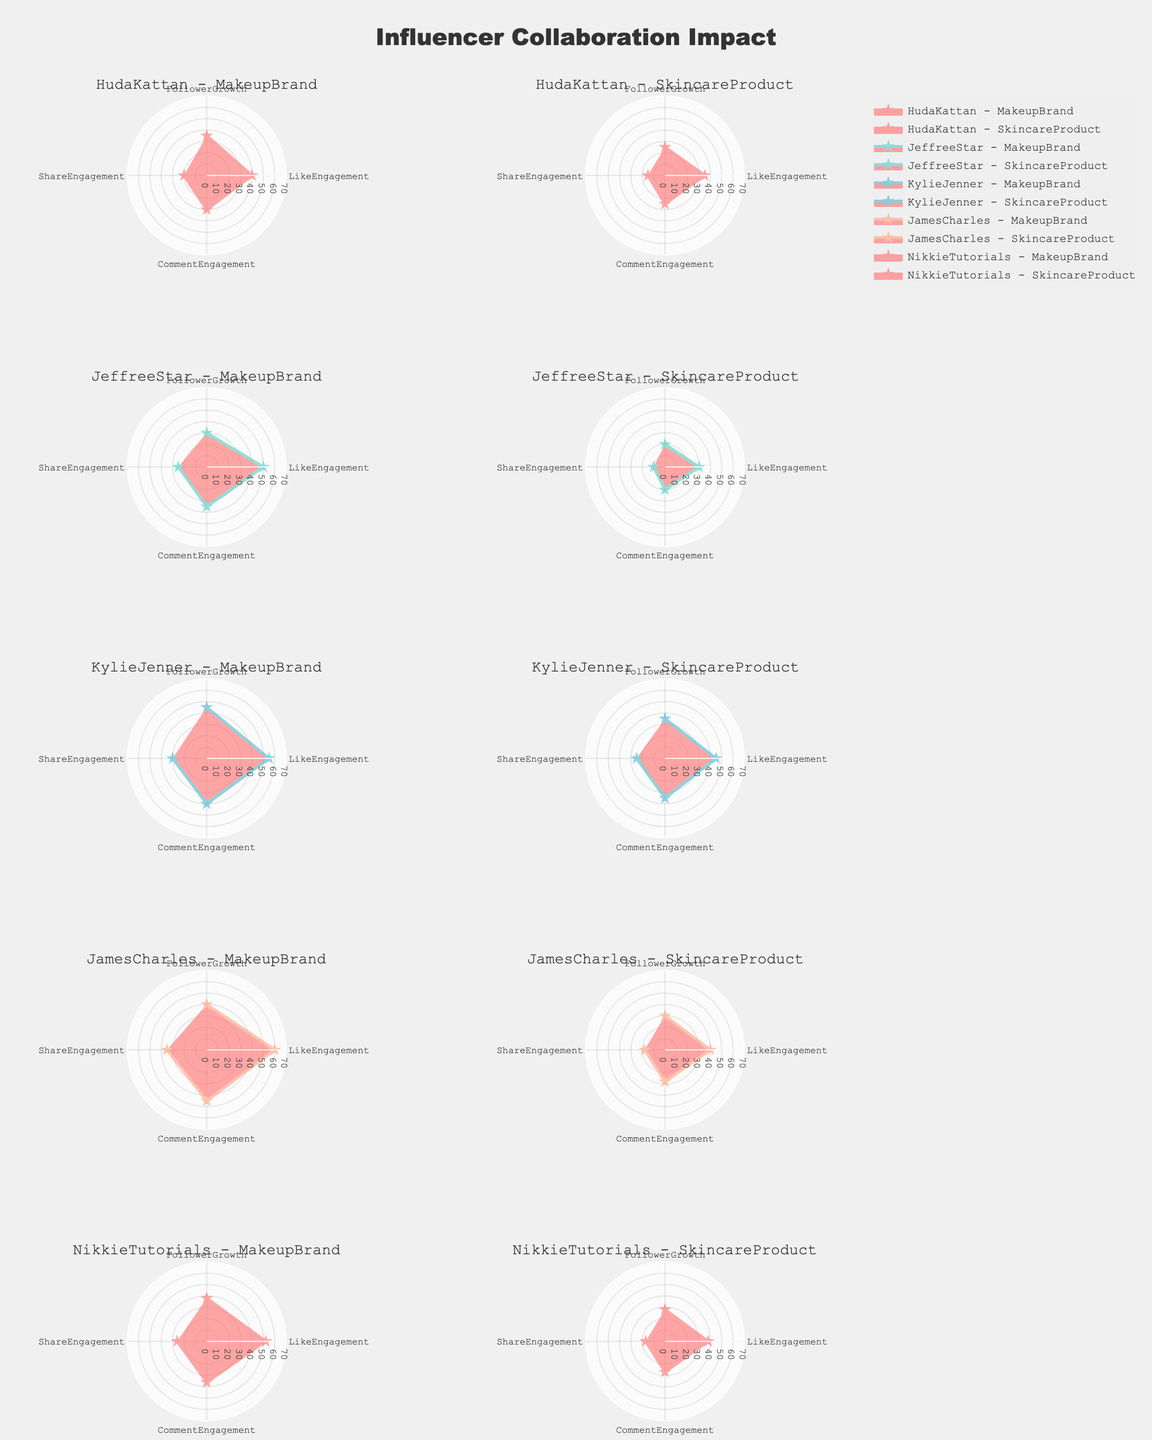What's the predominant color used for Kylie Jenner's collaborations? The color used for different influencers in the plots helps in identifying their data quickly. For Kylie Jenner, two subplots should be primarily characterized by a consistent color.
Answer: Pink Which influencer had the highest follower growth in makeup brand collaborations? By comparing the FollowerGrowth values in the makeup brand subplots of each influencer, we can see that Kylie Jenner's subplot has the highest radial distance.
Answer: Kylie Jenner Who has higher like engagement in skincare products, Huda Kattan or James Charles? Look at the LikeEngagement metric in the respective skincare product subplots for Huda Kattan and James Charles. The radial distance of Huda Kattan's like engagement is farther than that of James Charles.
Answer: Huda Kattan What is the average comment engagement for Jeffree Star across both types of collaborations? Add the CommentEngagement values for Jeffree Star's MakeupBrand (35) and SkincareProduct (20), then divide by 2. (35 + 20) / 2 = 27.5
Answer: 27.5 Which collaboration has the lowest share engagement for NikkieTutorials? Compare the ShareEngagement values in NikkieTutorials' subplots for both MakeupBrand and SkincareProduct. The value is lower for the skincare product.
Answer: SkincareProduct Which influencer's follower growth is the highest overall? By examining the radial extent of the FollowerGrowth metric across all subplots, we see Kylie Jenner's makeup brand collaboration has the highest.
Answer: Kylie Jenner How does James Charles's comment engagement in makeup brand compare to his skincare product? Analyze the CommentEngagement values for James Charles's subplots. The makeup brand has a higher radial distance (45) than the skincare product (28).
Answer: MakeupBrand is higher Which influencer had the smallest increase in like engagement when comparing makeup brand and skincare product collaborations? Calculate the difference in LikeEngagement for both collaboration types for each influencer and determine the smallest increase. James Charles had an increase from 40 to 60 (20), whereas others had larger differences.
Answer: Huda Kattan Overall, which influencer has the most balanced performance in all engagement metrics for makeup brand collaborations? By observing the radial distances for each metric in the makeup brand subplots, we see that Jeffree Star has relatively balanced distances across Like, Comment, and Share engagements, without extreme variations.
Answer: Jeffree Star 